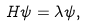Convert formula to latex. <formula><loc_0><loc_0><loc_500><loc_500>H \psi = \lambda \psi ,</formula> 